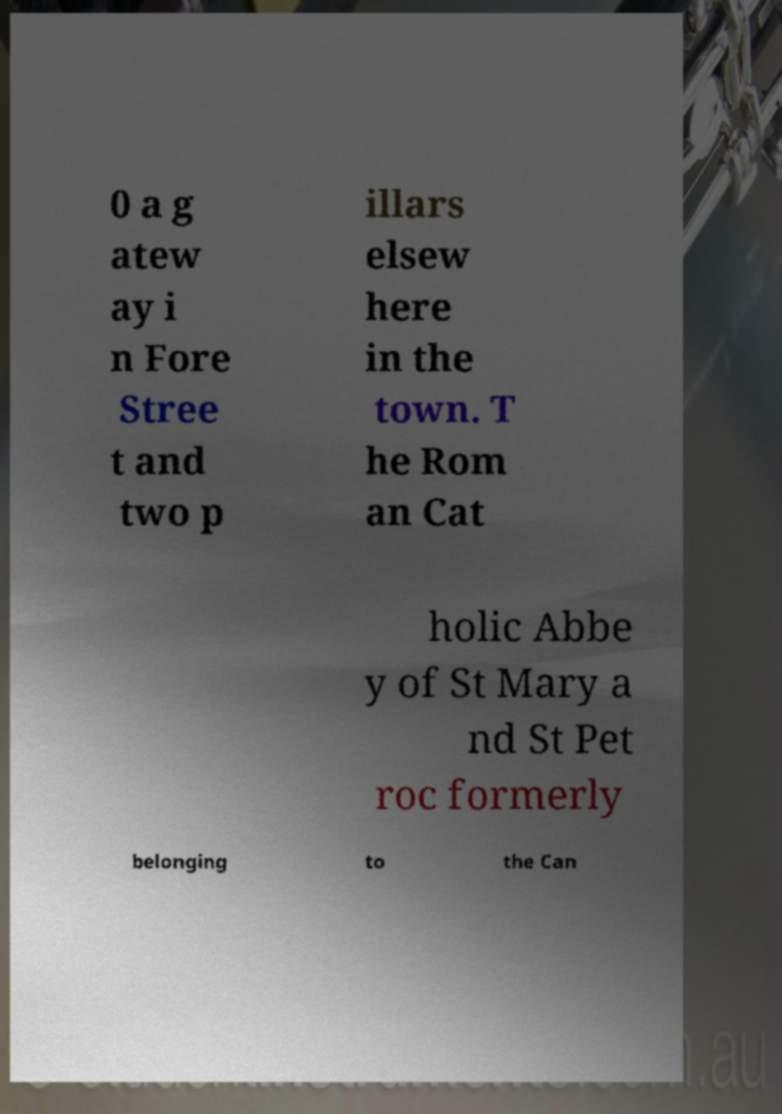Could you assist in decoding the text presented in this image and type it out clearly? 0 a g atew ay i n Fore Stree t and two p illars elsew here in the town. T he Rom an Cat holic Abbe y of St Mary a nd St Pet roc formerly belonging to the Can 